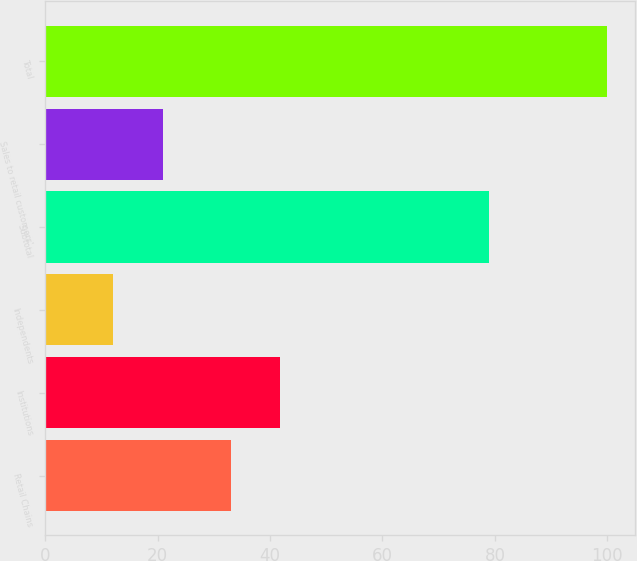Convert chart to OTSL. <chart><loc_0><loc_0><loc_500><loc_500><bar_chart><fcel>Retail Chains<fcel>Institutions<fcel>Independents<fcel>Subtotal<fcel>Sales to retail customers'<fcel>Total<nl><fcel>33<fcel>41.8<fcel>12<fcel>79<fcel>21<fcel>100<nl></chart> 